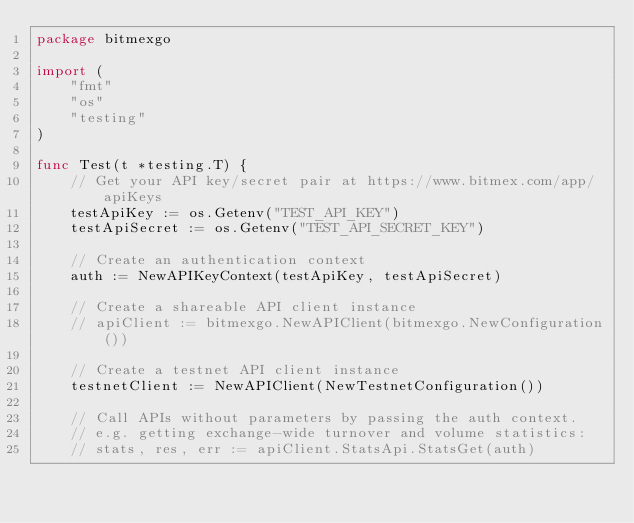Convert code to text. <code><loc_0><loc_0><loc_500><loc_500><_Go_>package bitmexgo

import (
	"fmt"
	"os"
	"testing"
)

func Test(t *testing.T) {
	// Get your API key/secret pair at https://www.bitmex.com/app/apiKeys
	testApiKey := os.Getenv("TEST_API_KEY")
	testApiSecret := os.Getenv("TEST_API_SECRET_KEY")

	// Create an authentication context
	auth := NewAPIKeyContext(testApiKey, testApiSecret)

	// Create a shareable API client instance
	// apiClient := bitmexgo.NewAPIClient(bitmexgo.NewConfiguration())

	// Create a testnet API client instance
	testnetClient := NewAPIClient(NewTestnetConfiguration())

	// Call APIs without parameters by passing the auth context.
	// e.g. getting exchange-wide turnover and volume statistics:
	// stats, res, err := apiClient.StatsApi.StatsGet(auth)
</code> 